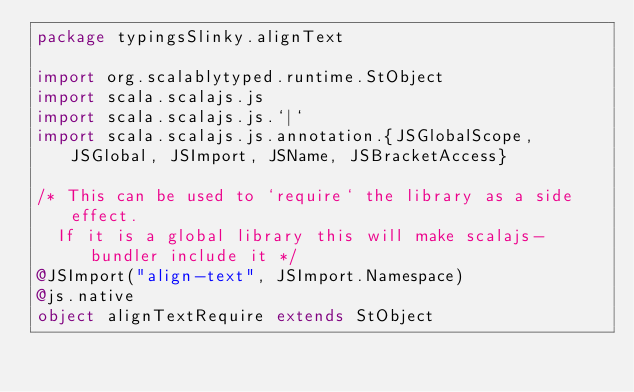<code> <loc_0><loc_0><loc_500><loc_500><_Scala_>package typingsSlinky.alignText

import org.scalablytyped.runtime.StObject
import scala.scalajs.js
import scala.scalajs.js.`|`
import scala.scalajs.js.annotation.{JSGlobalScope, JSGlobal, JSImport, JSName, JSBracketAccess}

/* This can be used to `require` the library as a side effect.
  If it is a global library this will make scalajs-bundler include it */
@JSImport("align-text", JSImport.Namespace)
@js.native
object alignTextRequire extends StObject
</code> 